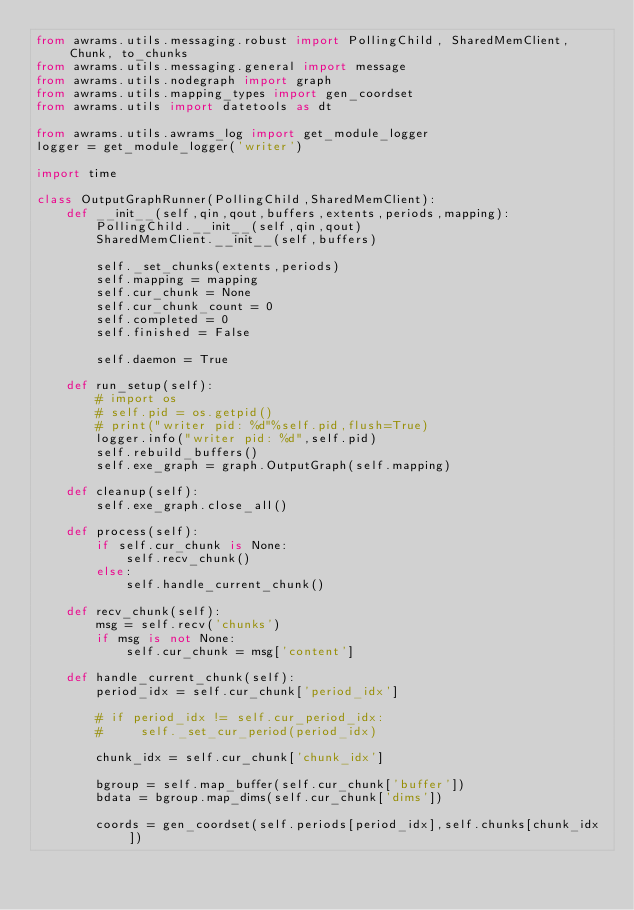<code> <loc_0><loc_0><loc_500><loc_500><_Python_>from awrams.utils.messaging.robust import PollingChild, SharedMemClient, Chunk, to_chunks
from awrams.utils.messaging.general import message
from awrams.utils.nodegraph import graph
from awrams.utils.mapping_types import gen_coordset
from awrams.utils import datetools as dt

from awrams.utils.awrams_log import get_module_logger
logger = get_module_logger('writer')

import time

class OutputGraphRunner(PollingChild,SharedMemClient):
    def __init__(self,qin,qout,buffers,extents,periods,mapping):
        PollingChild.__init__(self,qin,qout)
        SharedMemClient.__init__(self,buffers)

        self._set_chunks(extents,periods)
        self.mapping = mapping
        self.cur_chunk = None
        self.cur_chunk_count = 0
        self.completed = 0
        self.finished = False

        self.daemon = True

    def run_setup(self):
        # import os
        # self.pid = os.getpid()
        # print("writer pid: %d"%self.pid,flush=True)
        logger.info("writer pid: %d",self.pid)
        self.rebuild_buffers()
        self.exe_graph = graph.OutputGraph(self.mapping)

    def cleanup(self):
        self.exe_graph.close_all()

    def process(self):
        if self.cur_chunk is None:
            self.recv_chunk()
        else:
            self.handle_current_chunk()

    def recv_chunk(self):
        msg = self.recv('chunks')
        if msg is not None:
            self.cur_chunk = msg['content']

    def handle_current_chunk(self):
        period_idx = self.cur_chunk['period_idx']

        # if period_idx != self.cur_period_idx:
        #     self._set_cur_period(period_idx)

        chunk_idx = self.cur_chunk['chunk_idx']

        bgroup = self.map_buffer(self.cur_chunk['buffer'])
        bdata = bgroup.map_dims(self.cur_chunk['dims'])

        coords = gen_coordset(self.periods[period_idx],self.chunks[chunk_idx])</code> 